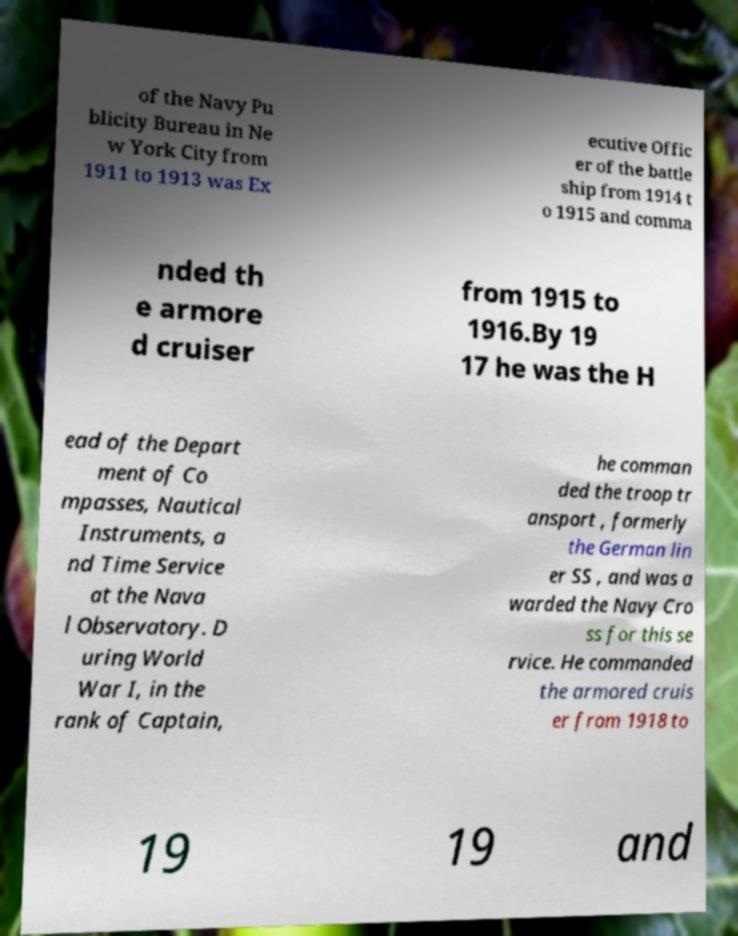For documentation purposes, I need the text within this image transcribed. Could you provide that? of the Navy Pu blicity Bureau in Ne w York City from 1911 to 1913 was Ex ecutive Offic er of the battle ship from 1914 t o 1915 and comma nded th e armore d cruiser from 1915 to 1916.By 19 17 he was the H ead of the Depart ment of Co mpasses, Nautical Instruments, a nd Time Service at the Nava l Observatory. D uring World War I, in the rank of Captain, he comman ded the troop tr ansport , formerly the German lin er SS , and was a warded the Navy Cro ss for this se rvice. He commanded the armored cruis er from 1918 to 19 19 and 